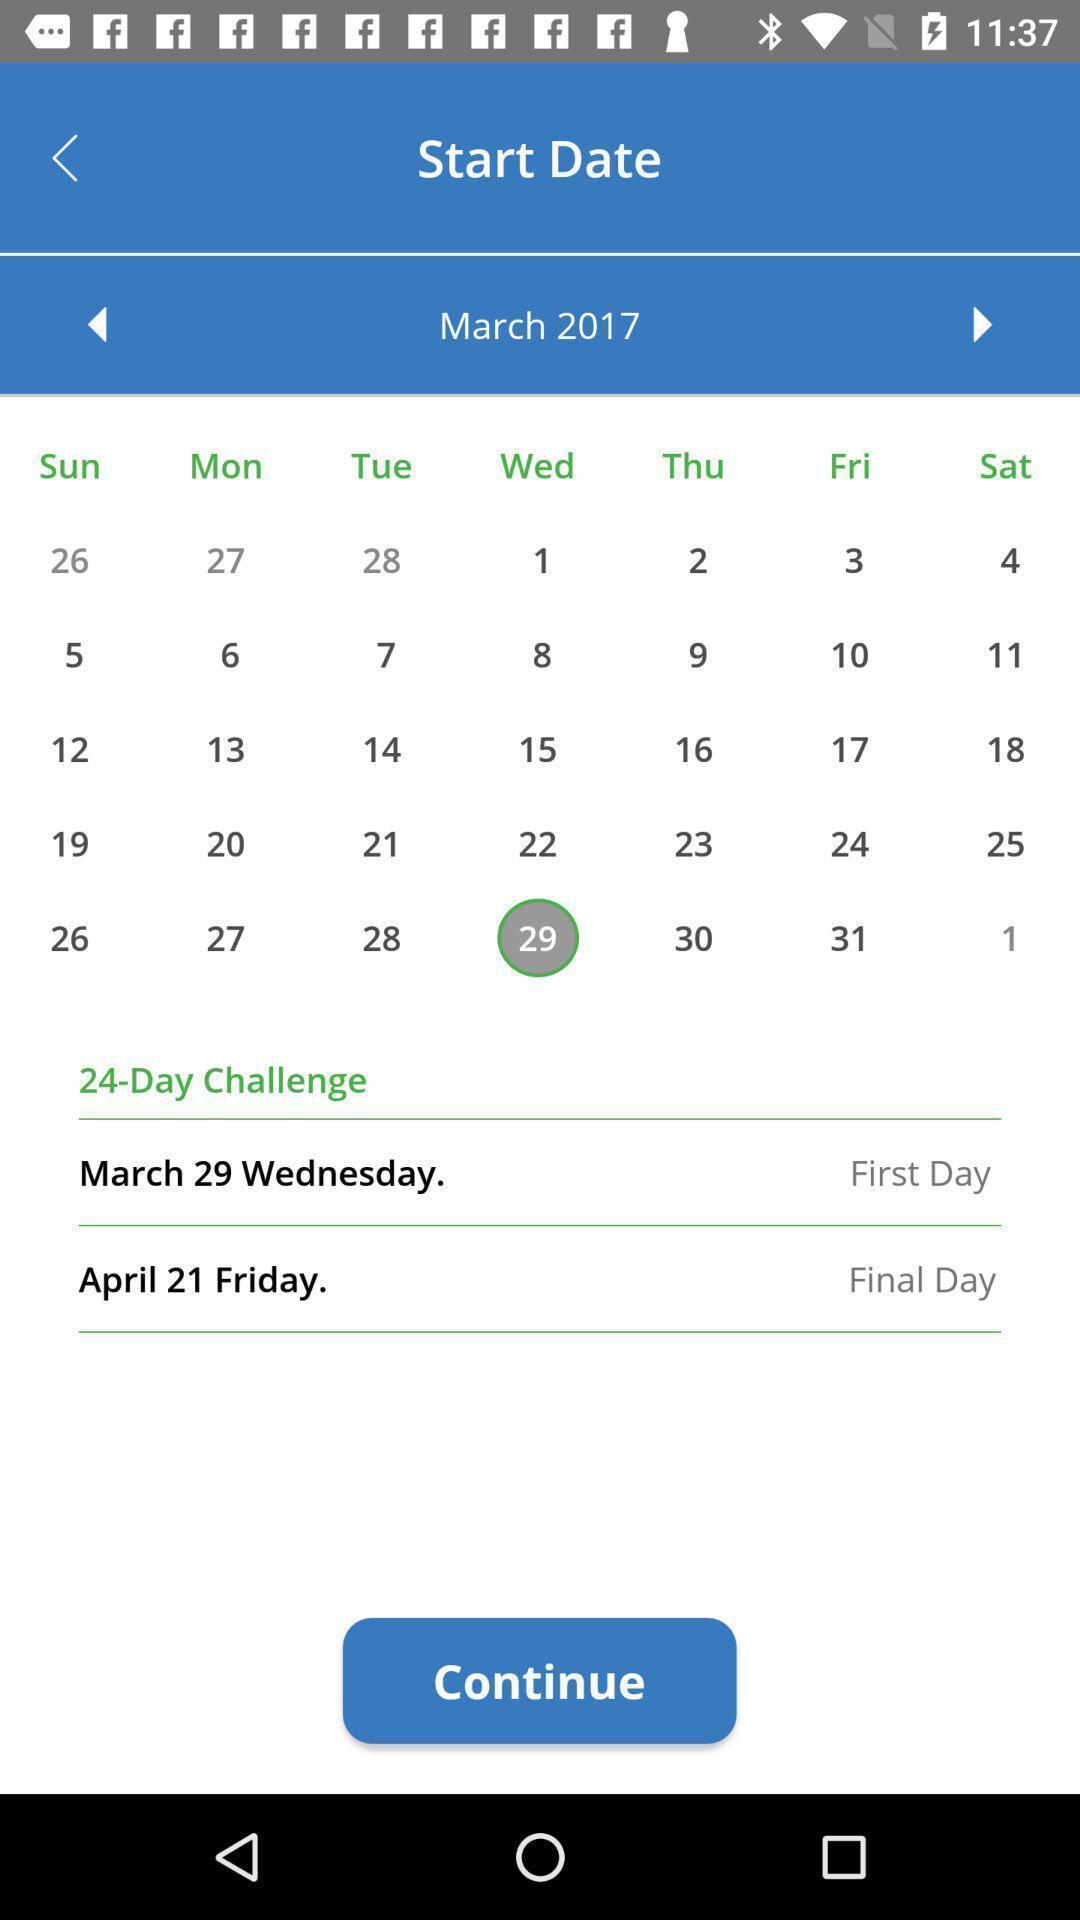Give me a narrative description of this picture. Start date page displaying calendar and info of an activity. 